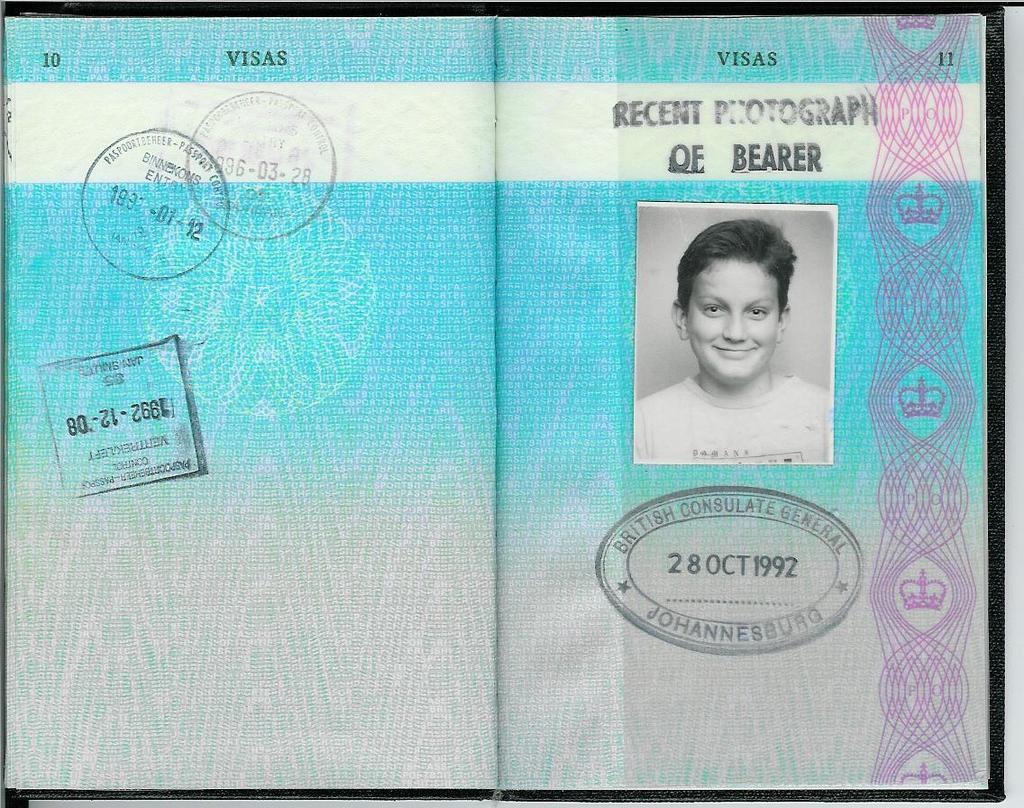How would you summarize this image in a sentence or two? In this picture we can see a book with a photo of a person, stamps and some text on it. 